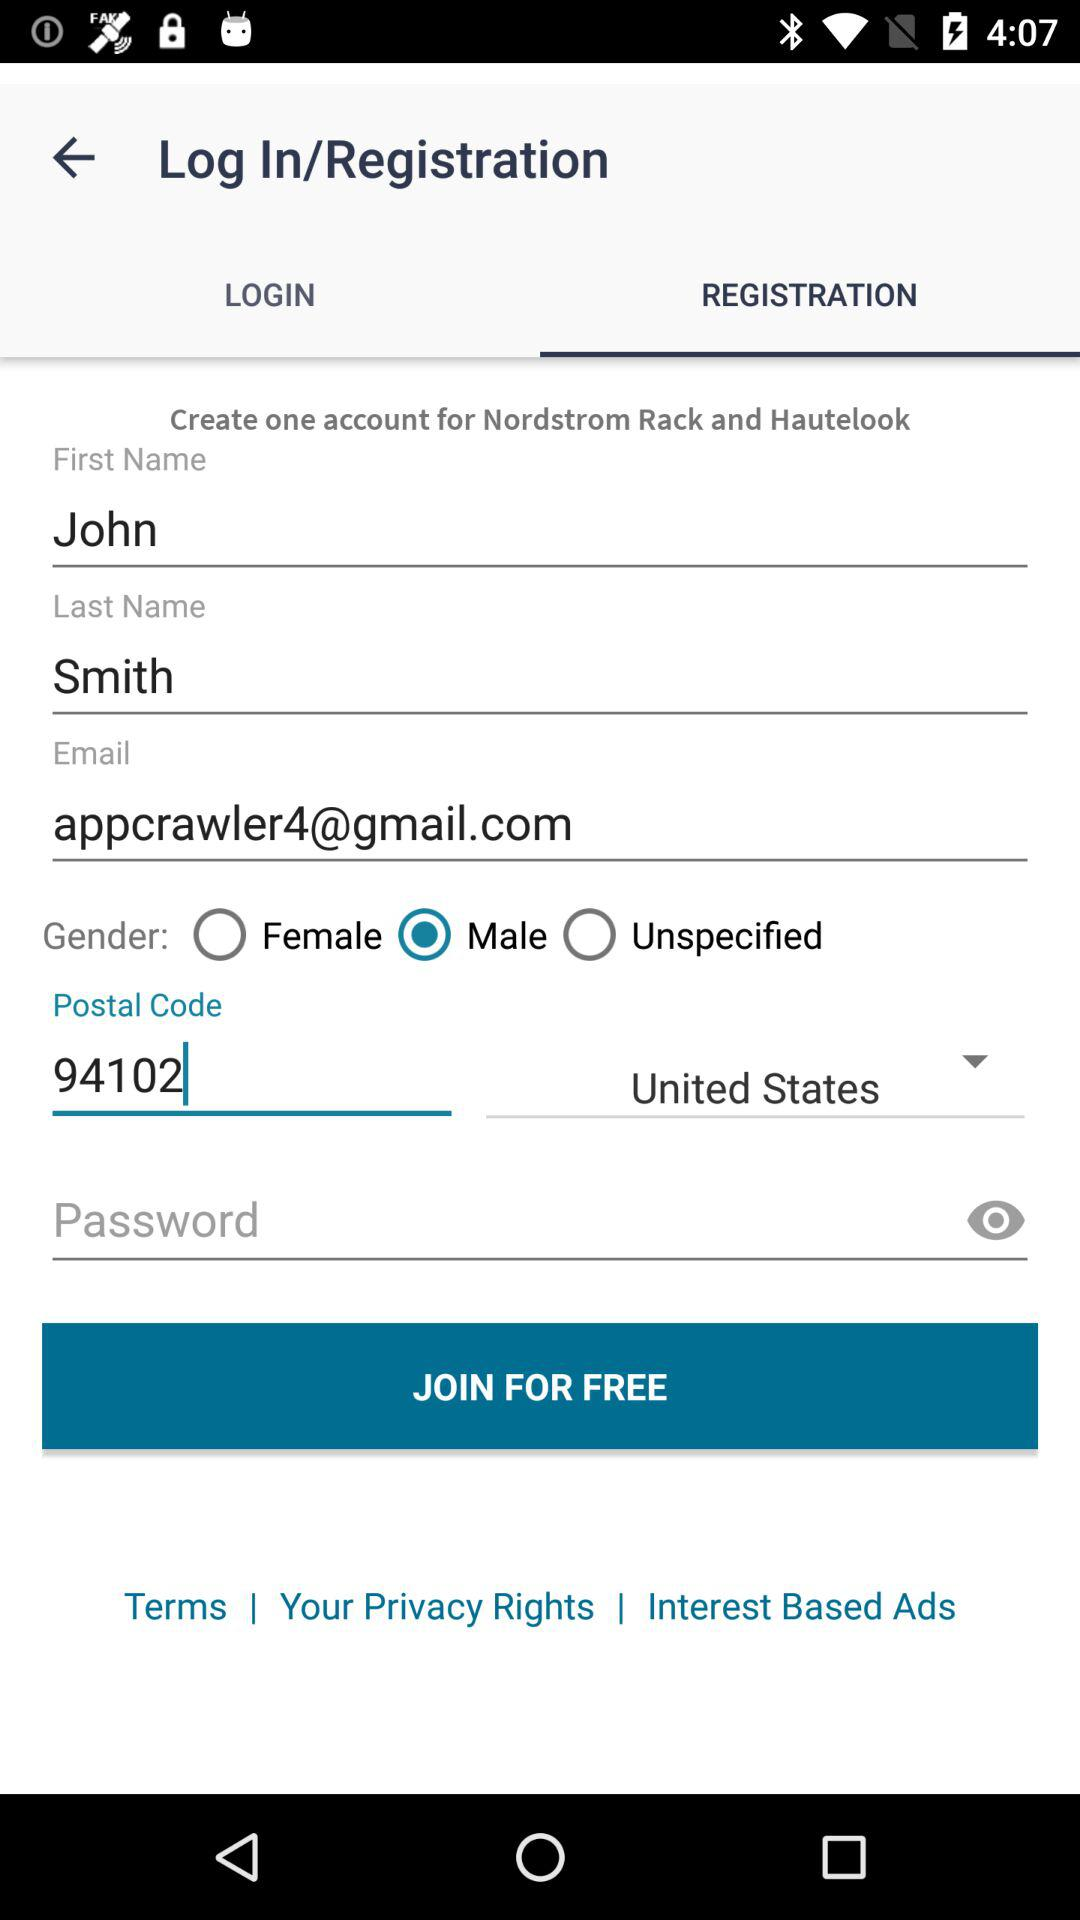What is the email address? The email address is appcrawler4@gmail.com. 